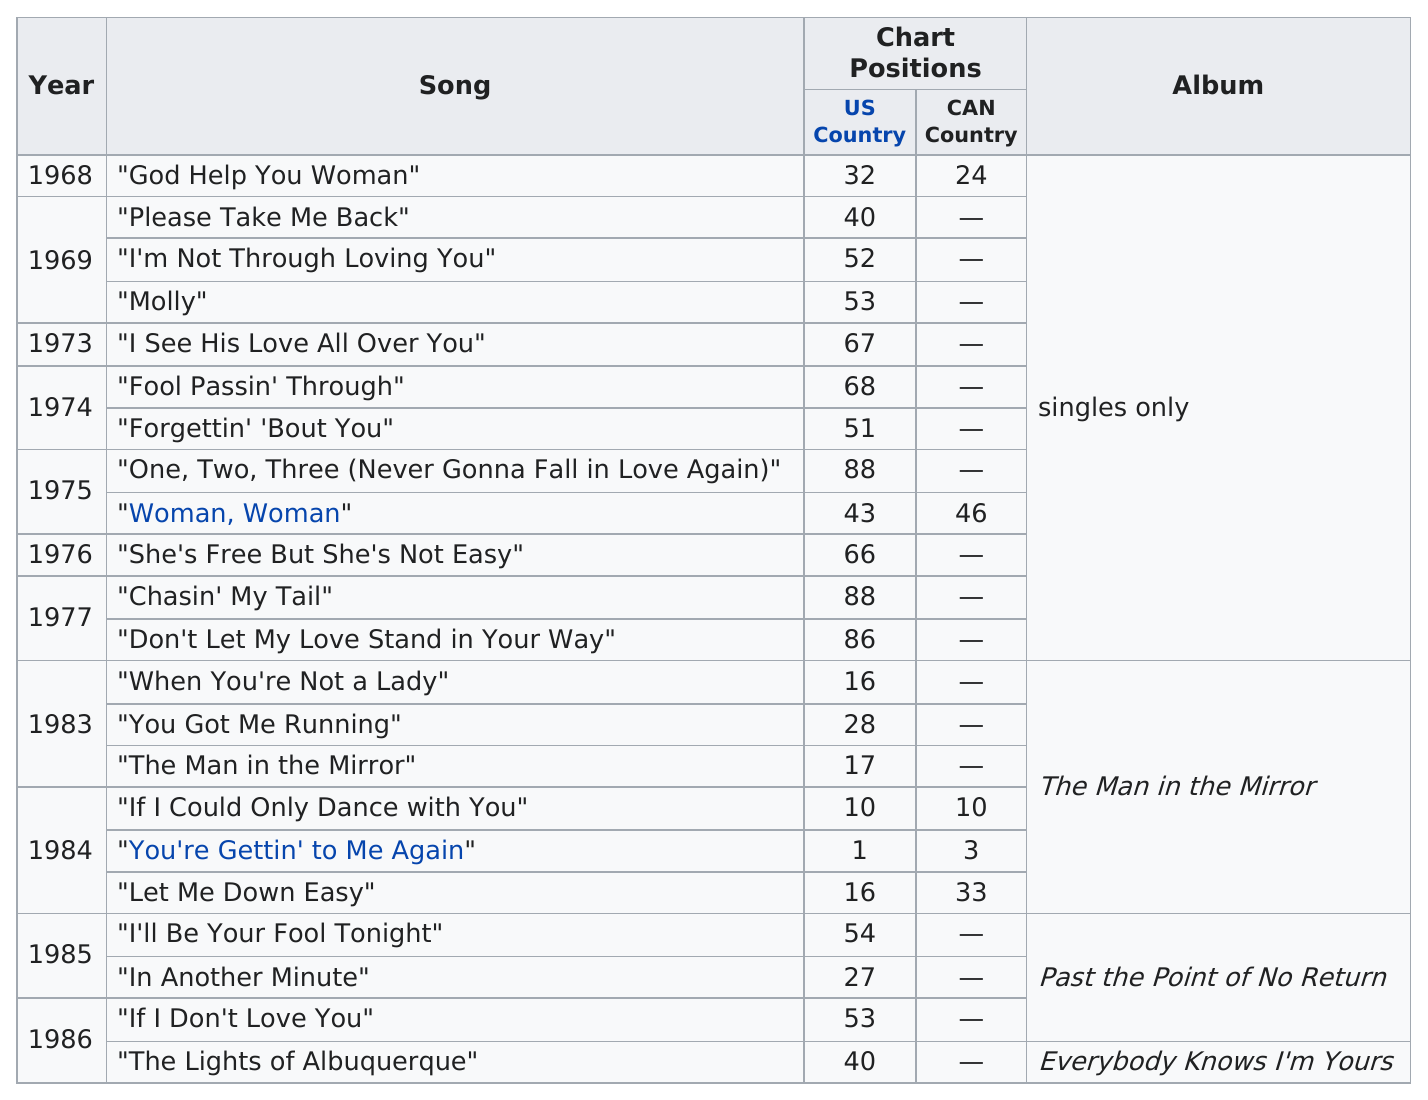Outline some significant characteristics in this image. The album that contained the most successful song in the charts was "The Man in the Mirror. The question asks for the number of songs released after a certain year, and the answer provided is 10. The number of songs that were not included on any album and were only released as a single is 12. The song titled "You're Gettin' to Me Again" had the highest US country position. The biggest difference in years between album release dates was 6... 